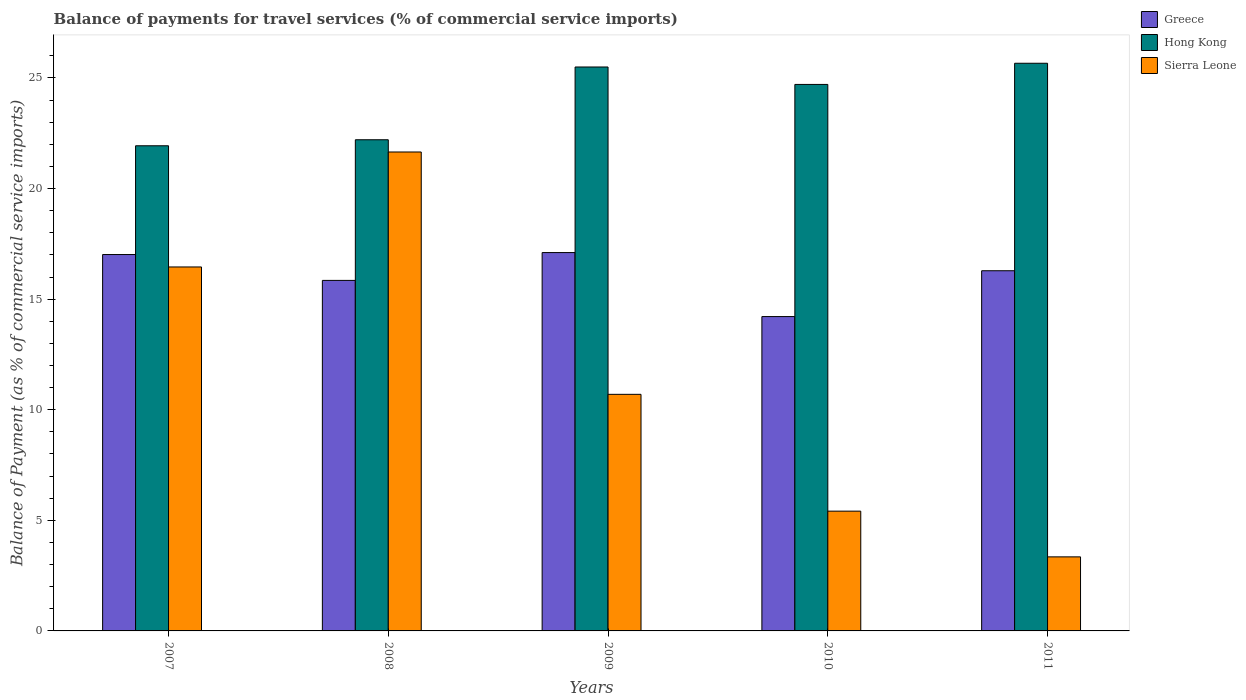Are the number of bars on each tick of the X-axis equal?
Offer a terse response. Yes. How many bars are there on the 2nd tick from the right?
Your response must be concise. 3. What is the label of the 4th group of bars from the left?
Make the answer very short. 2010. In how many cases, is the number of bars for a given year not equal to the number of legend labels?
Make the answer very short. 0. What is the balance of payments for travel services in Hong Kong in 2010?
Provide a short and direct response. 24.71. Across all years, what is the maximum balance of payments for travel services in Sierra Leone?
Provide a succinct answer. 21.65. Across all years, what is the minimum balance of payments for travel services in Hong Kong?
Your answer should be very brief. 21.93. In which year was the balance of payments for travel services in Hong Kong maximum?
Your answer should be very brief. 2011. In which year was the balance of payments for travel services in Hong Kong minimum?
Your response must be concise. 2007. What is the total balance of payments for travel services in Sierra Leone in the graph?
Provide a short and direct response. 57.57. What is the difference between the balance of payments for travel services in Hong Kong in 2008 and that in 2010?
Give a very brief answer. -2.5. What is the difference between the balance of payments for travel services in Sierra Leone in 2011 and the balance of payments for travel services in Hong Kong in 2008?
Your answer should be very brief. -18.86. What is the average balance of payments for travel services in Sierra Leone per year?
Keep it short and to the point. 11.51. In the year 2011, what is the difference between the balance of payments for travel services in Hong Kong and balance of payments for travel services in Greece?
Make the answer very short. 9.38. In how many years, is the balance of payments for travel services in Greece greater than 3 %?
Keep it short and to the point. 5. What is the ratio of the balance of payments for travel services in Sierra Leone in 2008 to that in 2010?
Offer a very short reply. 4. Is the balance of payments for travel services in Hong Kong in 2008 less than that in 2011?
Offer a very short reply. Yes. Is the difference between the balance of payments for travel services in Hong Kong in 2008 and 2011 greater than the difference between the balance of payments for travel services in Greece in 2008 and 2011?
Offer a very short reply. No. What is the difference between the highest and the second highest balance of payments for travel services in Greece?
Offer a terse response. 0.09. What is the difference between the highest and the lowest balance of payments for travel services in Hong Kong?
Your answer should be compact. 3.73. Is the sum of the balance of payments for travel services in Greece in 2007 and 2011 greater than the maximum balance of payments for travel services in Sierra Leone across all years?
Your answer should be compact. Yes. What does the 2nd bar from the left in 2009 represents?
Your answer should be very brief. Hong Kong. What does the 2nd bar from the right in 2010 represents?
Your response must be concise. Hong Kong. How many bars are there?
Provide a succinct answer. 15. Are all the bars in the graph horizontal?
Make the answer very short. No. Does the graph contain any zero values?
Keep it short and to the point. No. Where does the legend appear in the graph?
Make the answer very short. Top right. How are the legend labels stacked?
Give a very brief answer. Vertical. What is the title of the graph?
Your answer should be very brief. Balance of payments for travel services (% of commercial service imports). What is the label or title of the Y-axis?
Keep it short and to the point. Balance of Payment (as % of commercial service imports). What is the Balance of Payment (as % of commercial service imports) in Greece in 2007?
Offer a very short reply. 17.02. What is the Balance of Payment (as % of commercial service imports) in Hong Kong in 2007?
Provide a succinct answer. 21.93. What is the Balance of Payment (as % of commercial service imports) in Sierra Leone in 2007?
Provide a short and direct response. 16.46. What is the Balance of Payment (as % of commercial service imports) of Greece in 2008?
Keep it short and to the point. 15.85. What is the Balance of Payment (as % of commercial service imports) of Hong Kong in 2008?
Your response must be concise. 22.21. What is the Balance of Payment (as % of commercial service imports) in Sierra Leone in 2008?
Provide a short and direct response. 21.65. What is the Balance of Payment (as % of commercial service imports) of Greece in 2009?
Ensure brevity in your answer.  17.11. What is the Balance of Payment (as % of commercial service imports) of Hong Kong in 2009?
Offer a very short reply. 25.5. What is the Balance of Payment (as % of commercial service imports) in Sierra Leone in 2009?
Make the answer very short. 10.7. What is the Balance of Payment (as % of commercial service imports) of Greece in 2010?
Ensure brevity in your answer.  14.21. What is the Balance of Payment (as % of commercial service imports) of Hong Kong in 2010?
Keep it short and to the point. 24.71. What is the Balance of Payment (as % of commercial service imports) in Sierra Leone in 2010?
Ensure brevity in your answer.  5.42. What is the Balance of Payment (as % of commercial service imports) in Greece in 2011?
Your answer should be compact. 16.28. What is the Balance of Payment (as % of commercial service imports) of Hong Kong in 2011?
Give a very brief answer. 25.67. What is the Balance of Payment (as % of commercial service imports) of Sierra Leone in 2011?
Give a very brief answer. 3.35. Across all years, what is the maximum Balance of Payment (as % of commercial service imports) of Greece?
Offer a very short reply. 17.11. Across all years, what is the maximum Balance of Payment (as % of commercial service imports) in Hong Kong?
Make the answer very short. 25.67. Across all years, what is the maximum Balance of Payment (as % of commercial service imports) in Sierra Leone?
Give a very brief answer. 21.65. Across all years, what is the minimum Balance of Payment (as % of commercial service imports) in Greece?
Give a very brief answer. 14.21. Across all years, what is the minimum Balance of Payment (as % of commercial service imports) of Hong Kong?
Your answer should be very brief. 21.93. Across all years, what is the minimum Balance of Payment (as % of commercial service imports) of Sierra Leone?
Make the answer very short. 3.35. What is the total Balance of Payment (as % of commercial service imports) of Greece in the graph?
Offer a very short reply. 80.47. What is the total Balance of Payment (as % of commercial service imports) in Hong Kong in the graph?
Offer a very short reply. 120.01. What is the total Balance of Payment (as % of commercial service imports) of Sierra Leone in the graph?
Your response must be concise. 57.57. What is the difference between the Balance of Payment (as % of commercial service imports) of Greece in 2007 and that in 2008?
Your response must be concise. 1.17. What is the difference between the Balance of Payment (as % of commercial service imports) of Hong Kong in 2007 and that in 2008?
Make the answer very short. -0.27. What is the difference between the Balance of Payment (as % of commercial service imports) of Sierra Leone in 2007 and that in 2008?
Your answer should be compact. -5.2. What is the difference between the Balance of Payment (as % of commercial service imports) of Greece in 2007 and that in 2009?
Keep it short and to the point. -0.09. What is the difference between the Balance of Payment (as % of commercial service imports) of Hong Kong in 2007 and that in 2009?
Your response must be concise. -3.56. What is the difference between the Balance of Payment (as % of commercial service imports) of Sierra Leone in 2007 and that in 2009?
Your answer should be compact. 5.76. What is the difference between the Balance of Payment (as % of commercial service imports) in Greece in 2007 and that in 2010?
Keep it short and to the point. 2.81. What is the difference between the Balance of Payment (as % of commercial service imports) of Hong Kong in 2007 and that in 2010?
Offer a terse response. -2.77. What is the difference between the Balance of Payment (as % of commercial service imports) of Sierra Leone in 2007 and that in 2010?
Provide a succinct answer. 11.04. What is the difference between the Balance of Payment (as % of commercial service imports) in Greece in 2007 and that in 2011?
Make the answer very short. 0.73. What is the difference between the Balance of Payment (as % of commercial service imports) in Hong Kong in 2007 and that in 2011?
Provide a short and direct response. -3.73. What is the difference between the Balance of Payment (as % of commercial service imports) in Sierra Leone in 2007 and that in 2011?
Offer a terse response. 13.11. What is the difference between the Balance of Payment (as % of commercial service imports) of Greece in 2008 and that in 2009?
Your answer should be very brief. -1.26. What is the difference between the Balance of Payment (as % of commercial service imports) of Hong Kong in 2008 and that in 2009?
Offer a very short reply. -3.29. What is the difference between the Balance of Payment (as % of commercial service imports) in Sierra Leone in 2008 and that in 2009?
Give a very brief answer. 10.96. What is the difference between the Balance of Payment (as % of commercial service imports) in Greece in 2008 and that in 2010?
Provide a short and direct response. 1.64. What is the difference between the Balance of Payment (as % of commercial service imports) of Hong Kong in 2008 and that in 2010?
Your answer should be very brief. -2.5. What is the difference between the Balance of Payment (as % of commercial service imports) in Sierra Leone in 2008 and that in 2010?
Offer a terse response. 16.24. What is the difference between the Balance of Payment (as % of commercial service imports) of Greece in 2008 and that in 2011?
Your response must be concise. -0.44. What is the difference between the Balance of Payment (as % of commercial service imports) of Hong Kong in 2008 and that in 2011?
Your answer should be compact. -3.46. What is the difference between the Balance of Payment (as % of commercial service imports) of Sierra Leone in 2008 and that in 2011?
Your answer should be compact. 18.31. What is the difference between the Balance of Payment (as % of commercial service imports) of Greece in 2009 and that in 2010?
Your answer should be compact. 2.89. What is the difference between the Balance of Payment (as % of commercial service imports) in Hong Kong in 2009 and that in 2010?
Ensure brevity in your answer.  0.79. What is the difference between the Balance of Payment (as % of commercial service imports) in Sierra Leone in 2009 and that in 2010?
Make the answer very short. 5.28. What is the difference between the Balance of Payment (as % of commercial service imports) of Greece in 2009 and that in 2011?
Provide a short and direct response. 0.82. What is the difference between the Balance of Payment (as % of commercial service imports) of Hong Kong in 2009 and that in 2011?
Provide a short and direct response. -0.17. What is the difference between the Balance of Payment (as % of commercial service imports) of Sierra Leone in 2009 and that in 2011?
Your answer should be very brief. 7.35. What is the difference between the Balance of Payment (as % of commercial service imports) in Greece in 2010 and that in 2011?
Your response must be concise. -2.07. What is the difference between the Balance of Payment (as % of commercial service imports) in Hong Kong in 2010 and that in 2011?
Your answer should be compact. -0.96. What is the difference between the Balance of Payment (as % of commercial service imports) of Sierra Leone in 2010 and that in 2011?
Offer a terse response. 2.07. What is the difference between the Balance of Payment (as % of commercial service imports) of Greece in 2007 and the Balance of Payment (as % of commercial service imports) of Hong Kong in 2008?
Your answer should be very brief. -5.19. What is the difference between the Balance of Payment (as % of commercial service imports) in Greece in 2007 and the Balance of Payment (as % of commercial service imports) in Sierra Leone in 2008?
Provide a succinct answer. -4.64. What is the difference between the Balance of Payment (as % of commercial service imports) in Hong Kong in 2007 and the Balance of Payment (as % of commercial service imports) in Sierra Leone in 2008?
Give a very brief answer. 0.28. What is the difference between the Balance of Payment (as % of commercial service imports) of Greece in 2007 and the Balance of Payment (as % of commercial service imports) of Hong Kong in 2009?
Offer a terse response. -8.48. What is the difference between the Balance of Payment (as % of commercial service imports) of Greece in 2007 and the Balance of Payment (as % of commercial service imports) of Sierra Leone in 2009?
Your response must be concise. 6.32. What is the difference between the Balance of Payment (as % of commercial service imports) of Hong Kong in 2007 and the Balance of Payment (as % of commercial service imports) of Sierra Leone in 2009?
Give a very brief answer. 11.24. What is the difference between the Balance of Payment (as % of commercial service imports) of Greece in 2007 and the Balance of Payment (as % of commercial service imports) of Hong Kong in 2010?
Ensure brevity in your answer.  -7.69. What is the difference between the Balance of Payment (as % of commercial service imports) of Greece in 2007 and the Balance of Payment (as % of commercial service imports) of Sierra Leone in 2010?
Offer a very short reply. 11.6. What is the difference between the Balance of Payment (as % of commercial service imports) in Hong Kong in 2007 and the Balance of Payment (as % of commercial service imports) in Sierra Leone in 2010?
Give a very brief answer. 16.52. What is the difference between the Balance of Payment (as % of commercial service imports) in Greece in 2007 and the Balance of Payment (as % of commercial service imports) in Hong Kong in 2011?
Provide a succinct answer. -8.65. What is the difference between the Balance of Payment (as % of commercial service imports) in Greece in 2007 and the Balance of Payment (as % of commercial service imports) in Sierra Leone in 2011?
Provide a succinct answer. 13.67. What is the difference between the Balance of Payment (as % of commercial service imports) in Hong Kong in 2007 and the Balance of Payment (as % of commercial service imports) in Sierra Leone in 2011?
Ensure brevity in your answer.  18.59. What is the difference between the Balance of Payment (as % of commercial service imports) in Greece in 2008 and the Balance of Payment (as % of commercial service imports) in Hong Kong in 2009?
Provide a succinct answer. -9.65. What is the difference between the Balance of Payment (as % of commercial service imports) of Greece in 2008 and the Balance of Payment (as % of commercial service imports) of Sierra Leone in 2009?
Your answer should be very brief. 5.15. What is the difference between the Balance of Payment (as % of commercial service imports) in Hong Kong in 2008 and the Balance of Payment (as % of commercial service imports) in Sierra Leone in 2009?
Make the answer very short. 11.51. What is the difference between the Balance of Payment (as % of commercial service imports) of Greece in 2008 and the Balance of Payment (as % of commercial service imports) of Hong Kong in 2010?
Offer a very short reply. -8.86. What is the difference between the Balance of Payment (as % of commercial service imports) of Greece in 2008 and the Balance of Payment (as % of commercial service imports) of Sierra Leone in 2010?
Offer a very short reply. 10.43. What is the difference between the Balance of Payment (as % of commercial service imports) of Hong Kong in 2008 and the Balance of Payment (as % of commercial service imports) of Sierra Leone in 2010?
Give a very brief answer. 16.79. What is the difference between the Balance of Payment (as % of commercial service imports) of Greece in 2008 and the Balance of Payment (as % of commercial service imports) of Hong Kong in 2011?
Ensure brevity in your answer.  -9.82. What is the difference between the Balance of Payment (as % of commercial service imports) of Greece in 2008 and the Balance of Payment (as % of commercial service imports) of Sierra Leone in 2011?
Your answer should be compact. 12.5. What is the difference between the Balance of Payment (as % of commercial service imports) of Hong Kong in 2008 and the Balance of Payment (as % of commercial service imports) of Sierra Leone in 2011?
Your response must be concise. 18.86. What is the difference between the Balance of Payment (as % of commercial service imports) in Greece in 2009 and the Balance of Payment (as % of commercial service imports) in Hong Kong in 2010?
Make the answer very short. -7.6. What is the difference between the Balance of Payment (as % of commercial service imports) in Greece in 2009 and the Balance of Payment (as % of commercial service imports) in Sierra Leone in 2010?
Provide a succinct answer. 11.69. What is the difference between the Balance of Payment (as % of commercial service imports) in Hong Kong in 2009 and the Balance of Payment (as % of commercial service imports) in Sierra Leone in 2010?
Provide a short and direct response. 20.08. What is the difference between the Balance of Payment (as % of commercial service imports) in Greece in 2009 and the Balance of Payment (as % of commercial service imports) in Hong Kong in 2011?
Offer a terse response. -8.56. What is the difference between the Balance of Payment (as % of commercial service imports) in Greece in 2009 and the Balance of Payment (as % of commercial service imports) in Sierra Leone in 2011?
Keep it short and to the point. 13.76. What is the difference between the Balance of Payment (as % of commercial service imports) of Hong Kong in 2009 and the Balance of Payment (as % of commercial service imports) of Sierra Leone in 2011?
Your response must be concise. 22.15. What is the difference between the Balance of Payment (as % of commercial service imports) of Greece in 2010 and the Balance of Payment (as % of commercial service imports) of Hong Kong in 2011?
Make the answer very short. -11.45. What is the difference between the Balance of Payment (as % of commercial service imports) in Greece in 2010 and the Balance of Payment (as % of commercial service imports) in Sierra Leone in 2011?
Give a very brief answer. 10.86. What is the difference between the Balance of Payment (as % of commercial service imports) in Hong Kong in 2010 and the Balance of Payment (as % of commercial service imports) in Sierra Leone in 2011?
Your answer should be compact. 21.36. What is the average Balance of Payment (as % of commercial service imports) in Greece per year?
Give a very brief answer. 16.09. What is the average Balance of Payment (as % of commercial service imports) in Hong Kong per year?
Provide a short and direct response. 24. What is the average Balance of Payment (as % of commercial service imports) in Sierra Leone per year?
Give a very brief answer. 11.51. In the year 2007, what is the difference between the Balance of Payment (as % of commercial service imports) in Greece and Balance of Payment (as % of commercial service imports) in Hong Kong?
Your answer should be compact. -4.92. In the year 2007, what is the difference between the Balance of Payment (as % of commercial service imports) in Greece and Balance of Payment (as % of commercial service imports) in Sierra Leone?
Your answer should be compact. 0.56. In the year 2007, what is the difference between the Balance of Payment (as % of commercial service imports) of Hong Kong and Balance of Payment (as % of commercial service imports) of Sierra Leone?
Offer a terse response. 5.48. In the year 2008, what is the difference between the Balance of Payment (as % of commercial service imports) in Greece and Balance of Payment (as % of commercial service imports) in Hong Kong?
Your answer should be compact. -6.36. In the year 2008, what is the difference between the Balance of Payment (as % of commercial service imports) of Greece and Balance of Payment (as % of commercial service imports) of Sierra Leone?
Offer a terse response. -5.81. In the year 2008, what is the difference between the Balance of Payment (as % of commercial service imports) in Hong Kong and Balance of Payment (as % of commercial service imports) in Sierra Leone?
Ensure brevity in your answer.  0.55. In the year 2009, what is the difference between the Balance of Payment (as % of commercial service imports) of Greece and Balance of Payment (as % of commercial service imports) of Hong Kong?
Offer a very short reply. -8.39. In the year 2009, what is the difference between the Balance of Payment (as % of commercial service imports) in Greece and Balance of Payment (as % of commercial service imports) in Sierra Leone?
Your response must be concise. 6.41. In the year 2009, what is the difference between the Balance of Payment (as % of commercial service imports) in Hong Kong and Balance of Payment (as % of commercial service imports) in Sierra Leone?
Provide a succinct answer. 14.8. In the year 2010, what is the difference between the Balance of Payment (as % of commercial service imports) in Greece and Balance of Payment (as % of commercial service imports) in Hong Kong?
Offer a very short reply. -10.5. In the year 2010, what is the difference between the Balance of Payment (as % of commercial service imports) in Greece and Balance of Payment (as % of commercial service imports) in Sierra Leone?
Offer a terse response. 8.8. In the year 2010, what is the difference between the Balance of Payment (as % of commercial service imports) of Hong Kong and Balance of Payment (as % of commercial service imports) of Sierra Leone?
Your response must be concise. 19.29. In the year 2011, what is the difference between the Balance of Payment (as % of commercial service imports) of Greece and Balance of Payment (as % of commercial service imports) of Hong Kong?
Offer a very short reply. -9.38. In the year 2011, what is the difference between the Balance of Payment (as % of commercial service imports) of Greece and Balance of Payment (as % of commercial service imports) of Sierra Leone?
Ensure brevity in your answer.  12.94. In the year 2011, what is the difference between the Balance of Payment (as % of commercial service imports) in Hong Kong and Balance of Payment (as % of commercial service imports) in Sierra Leone?
Keep it short and to the point. 22.32. What is the ratio of the Balance of Payment (as % of commercial service imports) in Greece in 2007 to that in 2008?
Offer a very short reply. 1.07. What is the ratio of the Balance of Payment (as % of commercial service imports) of Sierra Leone in 2007 to that in 2008?
Keep it short and to the point. 0.76. What is the ratio of the Balance of Payment (as % of commercial service imports) in Hong Kong in 2007 to that in 2009?
Offer a very short reply. 0.86. What is the ratio of the Balance of Payment (as % of commercial service imports) in Sierra Leone in 2007 to that in 2009?
Your answer should be very brief. 1.54. What is the ratio of the Balance of Payment (as % of commercial service imports) of Greece in 2007 to that in 2010?
Provide a short and direct response. 1.2. What is the ratio of the Balance of Payment (as % of commercial service imports) in Hong Kong in 2007 to that in 2010?
Your answer should be compact. 0.89. What is the ratio of the Balance of Payment (as % of commercial service imports) in Sierra Leone in 2007 to that in 2010?
Your answer should be compact. 3.04. What is the ratio of the Balance of Payment (as % of commercial service imports) of Greece in 2007 to that in 2011?
Give a very brief answer. 1.04. What is the ratio of the Balance of Payment (as % of commercial service imports) in Hong Kong in 2007 to that in 2011?
Make the answer very short. 0.85. What is the ratio of the Balance of Payment (as % of commercial service imports) of Sierra Leone in 2007 to that in 2011?
Make the answer very short. 4.92. What is the ratio of the Balance of Payment (as % of commercial service imports) of Greece in 2008 to that in 2009?
Give a very brief answer. 0.93. What is the ratio of the Balance of Payment (as % of commercial service imports) in Hong Kong in 2008 to that in 2009?
Keep it short and to the point. 0.87. What is the ratio of the Balance of Payment (as % of commercial service imports) in Sierra Leone in 2008 to that in 2009?
Ensure brevity in your answer.  2.02. What is the ratio of the Balance of Payment (as % of commercial service imports) of Greece in 2008 to that in 2010?
Offer a terse response. 1.12. What is the ratio of the Balance of Payment (as % of commercial service imports) in Hong Kong in 2008 to that in 2010?
Keep it short and to the point. 0.9. What is the ratio of the Balance of Payment (as % of commercial service imports) of Sierra Leone in 2008 to that in 2010?
Ensure brevity in your answer.  4. What is the ratio of the Balance of Payment (as % of commercial service imports) of Greece in 2008 to that in 2011?
Your answer should be very brief. 0.97. What is the ratio of the Balance of Payment (as % of commercial service imports) of Hong Kong in 2008 to that in 2011?
Provide a short and direct response. 0.87. What is the ratio of the Balance of Payment (as % of commercial service imports) in Sierra Leone in 2008 to that in 2011?
Give a very brief answer. 6.47. What is the ratio of the Balance of Payment (as % of commercial service imports) of Greece in 2009 to that in 2010?
Provide a succinct answer. 1.2. What is the ratio of the Balance of Payment (as % of commercial service imports) of Hong Kong in 2009 to that in 2010?
Your answer should be very brief. 1.03. What is the ratio of the Balance of Payment (as % of commercial service imports) in Sierra Leone in 2009 to that in 2010?
Provide a succinct answer. 1.98. What is the ratio of the Balance of Payment (as % of commercial service imports) of Greece in 2009 to that in 2011?
Offer a terse response. 1.05. What is the ratio of the Balance of Payment (as % of commercial service imports) of Hong Kong in 2009 to that in 2011?
Your response must be concise. 0.99. What is the ratio of the Balance of Payment (as % of commercial service imports) in Sierra Leone in 2009 to that in 2011?
Offer a very short reply. 3.19. What is the ratio of the Balance of Payment (as % of commercial service imports) of Greece in 2010 to that in 2011?
Keep it short and to the point. 0.87. What is the ratio of the Balance of Payment (as % of commercial service imports) of Hong Kong in 2010 to that in 2011?
Give a very brief answer. 0.96. What is the ratio of the Balance of Payment (as % of commercial service imports) of Sierra Leone in 2010 to that in 2011?
Provide a succinct answer. 1.62. What is the difference between the highest and the second highest Balance of Payment (as % of commercial service imports) of Greece?
Provide a succinct answer. 0.09. What is the difference between the highest and the second highest Balance of Payment (as % of commercial service imports) of Hong Kong?
Provide a succinct answer. 0.17. What is the difference between the highest and the second highest Balance of Payment (as % of commercial service imports) of Sierra Leone?
Your answer should be compact. 5.2. What is the difference between the highest and the lowest Balance of Payment (as % of commercial service imports) in Greece?
Provide a short and direct response. 2.89. What is the difference between the highest and the lowest Balance of Payment (as % of commercial service imports) in Hong Kong?
Ensure brevity in your answer.  3.73. What is the difference between the highest and the lowest Balance of Payment (as % of commercial service imports) of Sierra Leone?
Your response must be concise. 18.31. 